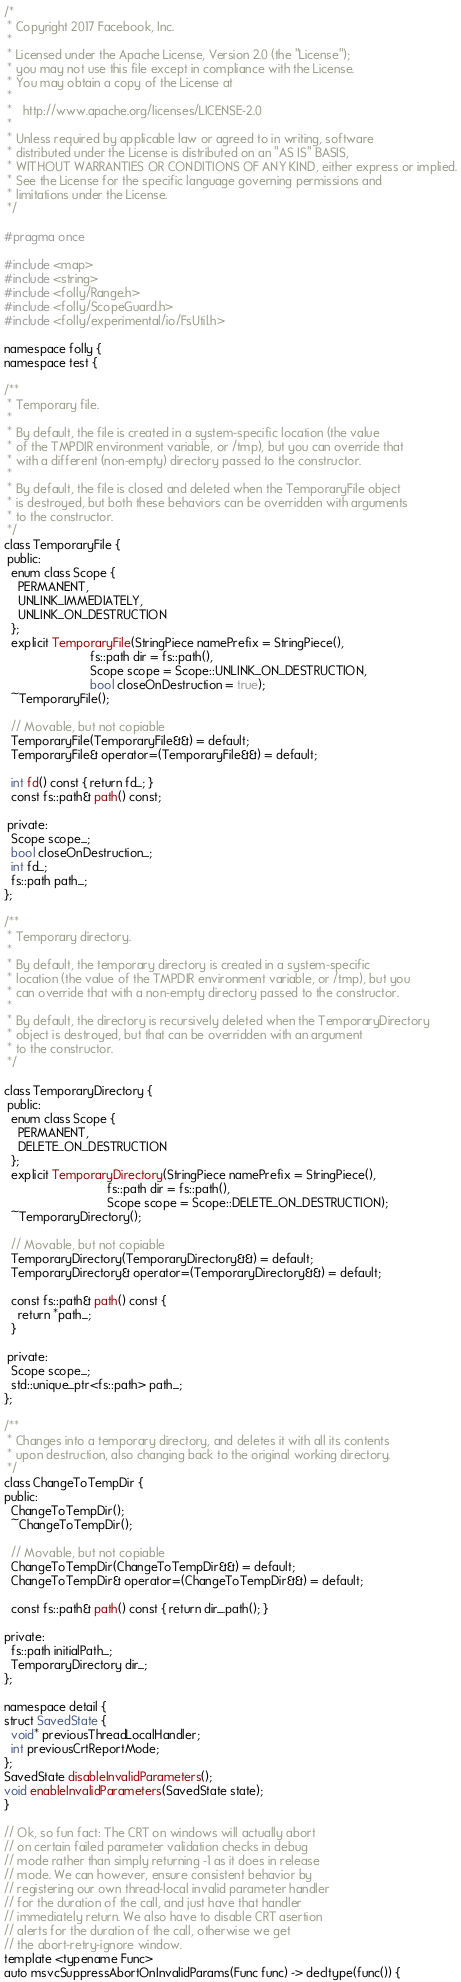<code> <loc_0><loc_0><loc_500><loc_500><_C_>/*
 * Copyright 2017 Facebook, Inc.
 *
 * Licensed under the Apache License, Version 2.0 (the "License");
 * you may not use this file except in compliance with the License.
 * You may obtain a copy of the License at
 *
 *   http://www.apache.org/licenses/LICENSE-2.0
 *
 * Unless required by applicable law or agreed to in writing, software
 * distributed under the License is distributed on an "AS IS" BASIS,
 * WITHOUT WARRANTIES OR CONDITIONS OF ANY KIND, either express or implied.
 * See the License for the specific language governing permissions and
 * limitations under the License.
 */

#pragma once

#include <map>
#include <string>
#include <folly/Range.h>
#include <folly/ScopeGuard.h>
#include <folly/experimental/io/FsUtil.h>

namespace folly {
namespace test {

/**
 * Temporary file.
 *
 * By default, the file is created in a system-specific location (the value
 * of the TMPDIR environment variable, or /tmp), but you can override that
 * with a different (non-empty) directory passed to the constructor.
 *
 * By default, the file is closed and deleted when the TemporaryFile object
 * is destroyed, but both these behaviors can be overridden with arguments
 * to the constructor.
 */
class TemporaryFile {
 public:
  enum class Scope {
    PERMANENT,
    UNLINK_IMMEDIATELY,
    UNLINK_ON_DESTRUCTION
  };
  explicit TemporaryFile(StringPiece namePrefix = StringPiece(),
                         fs::path dir = fs::path(),
                         Scope scope = Scope::UNLINK_ON_DESTRUCTION,
                         bool closeOnDestruction = true);
  ~TemporaryFile();

  // Movable, but not copiable
  TemporaryFile(TemporaryFile&&) = default;
  TemporaryFile& operator=(TemporaryFile&&) = default;

  int fd() const { return fd_; }
  const fs::path& path() const;

 private:
  Scope scope_;
  bool closeOnDestruction_;
  int fd_;
  fs::path path_;
};

/**
 * Temporary directory.
 *
 * By default, the temporary directory is created in a system-specific
 * location (the value of the TMPDIR environment variable, or /tmp), but you
 * can override that with a non-empty directory passed to the constructor.
 *
 * By default, the directory is recursively deleted when the TemporaryDirectory
 * object is destroyed, but that can be overridden with an argument
 * to the constructor.
 */

class TemporaryDirectory {
 public:
  enum class Scope {
    PERMANENT,
    DELETE_ON_DESTRUCTION
  };
  explicit TemporaryDirectory(StringPiece namePrefix = StringPiece(),
                              fs::path dir = fs::path(),
                              Scope scope = Scope::DELETE_ON_DESTRUCTION);
  ~TemporaryDirectory();

  // Movable, but not copiable
  TemporaryDirectory(TemporaryDirectory&&) = default;
  TemporaryDirectory& operator=(TemporaryDirectory&&) = default;

  const fs::path& path() const {
    return *path_;
  }

 private:
  Scope scope_;
  std::unique_ptr<fs::path> path_;
};

/**
 * Changes into a temporary directory, and deletes it with all its contents
 * upon destruction, also changing back to the original working directory.
 */
class ChangeToTempDir {
public:
  ChangeToTempDir();
  ~ChangeToTempDir();

  // Movable, but not copiable
  ChangeToTempDir(ChangeToTempDir&&) = default;
  ChangeToTempDir& operator=(ChangeToTempDir&&) = default;

  const fs::path& path() const { return dir_.path(); }

private:
  fs::path initialPath_;
  TemporaryDirectory dir_;
};

namespace detail {
struct SavedState {
  void* previousThreadLocalHandler;
  int previousCrtReportMode;
};
SavedState disableInvalidParameters();
void enableInvalidParameters(SavedState state);
}

// Ok, so fun fact: The CRT on windows will actually abort
// on certain failed parameter validation checks in debug
// mode rather than simply returning -1 as it does in release
// mode. We can however, ensure consistent behavior by
// registering our own thread-local invalid parameter handler
// for the duration of the call, and just have that handler
// immediately return. We also have to disable CRT asertion
// alerts for the duration of the call, otherwise we get
// the abort-retry-ignore window.
template <typename Func>
auto msvcSuppressAbortOnInvalidParams(Func func) -> decltype(func()) {</code> 